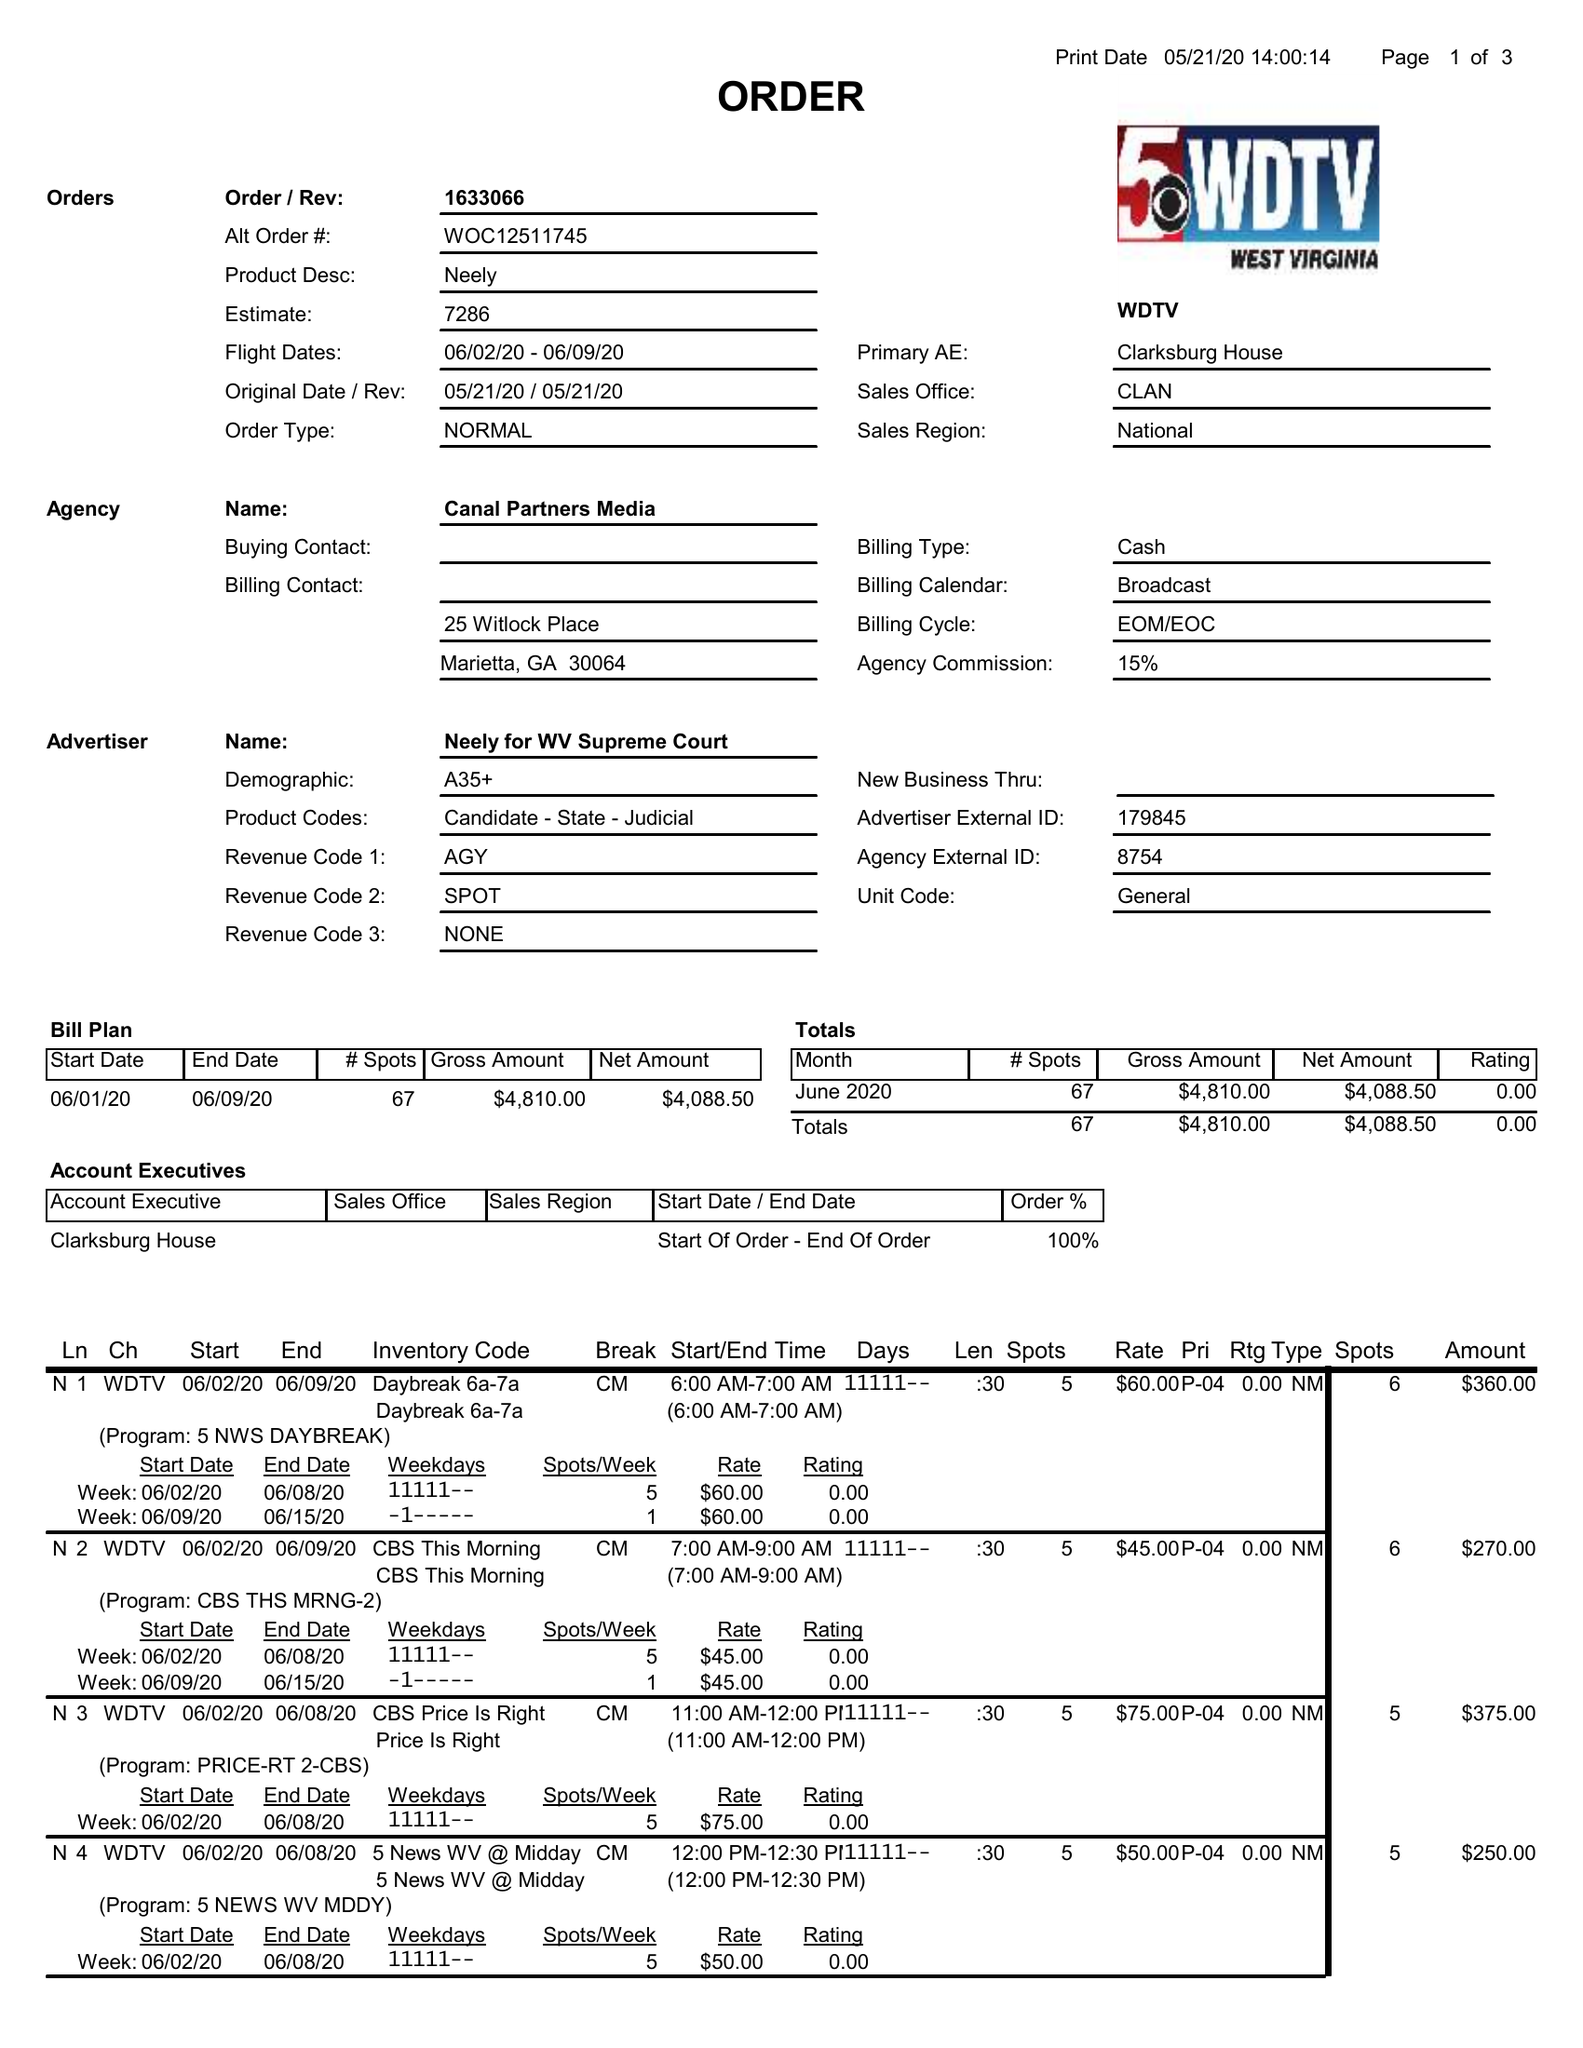What is the value for the contract_num?
Answer the question using a single word or phrase. 1633066 